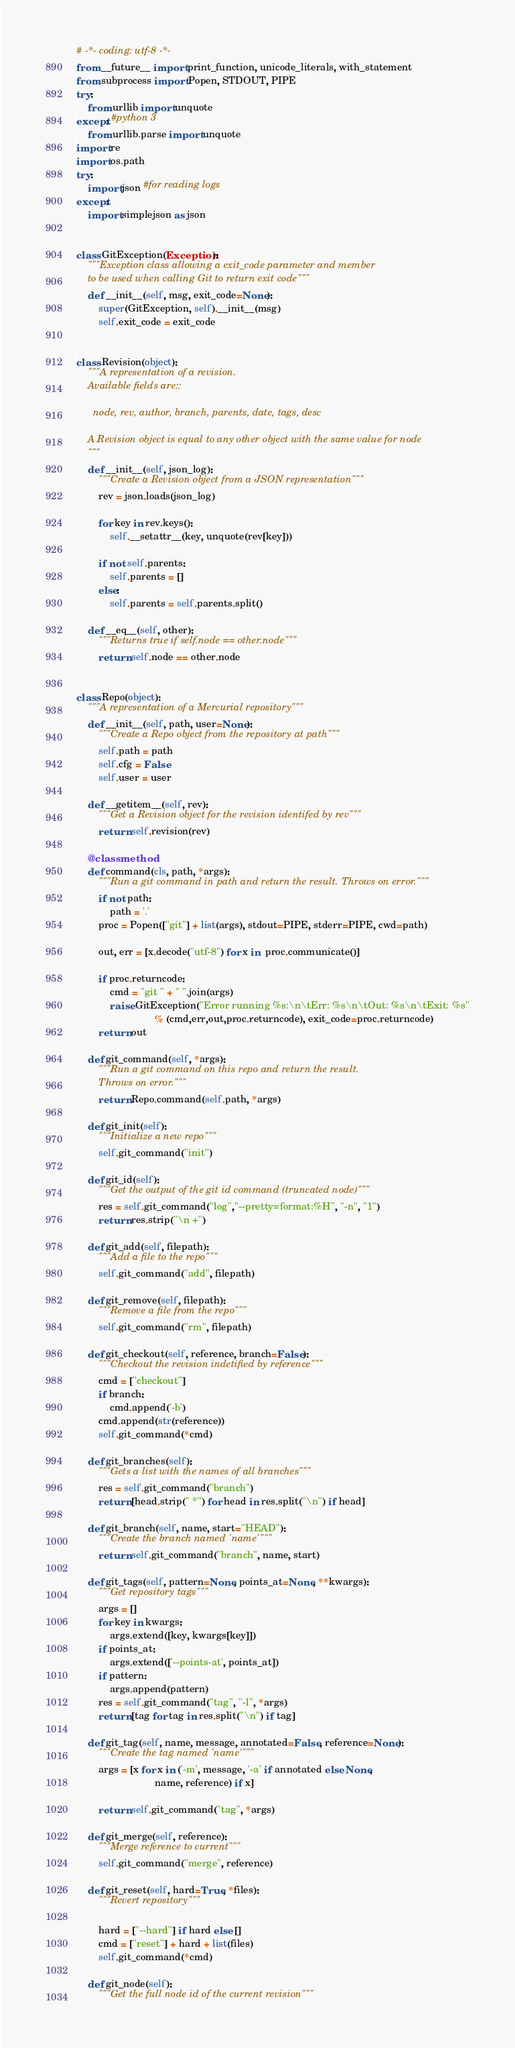<code> <loc_0><loc_0><loc_500><loc_500><_Python_># -*- coding: utf-8 -*-
from __future__ import print_function, unicode_literals, with_statement
from subprocess import Popen, STDOUT, PIPE
try:
    from urllib import unquote
except: #python 3
    from urllib.parse import unquote
import re
import os.path
try:
    import json #for reading logs
except:
    import simplejson as json


class GitException(Exception):
    """Exception class allowing a exit_code parameter and member
    to be used when calling Git to return exit code"""
    def __init__(self, msg, exit_code=None):
        super(GitException, self).__init__(msg)
        self.exit_code = exit_code


class Revision(object):
    """A representation of a revision.
    Available fields are::

      node, rev, author, branch, parents, date, tags, desc

    A Revision object is equal to any other object with the same value for node
    """
    def __init__(self, json_log):
        """Create a Revision object from a JSON representation"""
        rev = json.loads(json_log)

        for key in rev.keys():
            self.__setattr__(key, unquote(rev[key]))

        if not self.parents:
            self.parents = []
        else:
            self.parents = self.parents.split()

    def __eq__(self, other):
        """Returns true if self.node == other.node"""
        return self.node == other.node


class Repo(object):
    """A representation of a Mercurial repository"""
    def __init__(self, path, user=None):
        """Create a Repo object from the repository at path"""
        self.path = path
        self.cfg = False
        self.user = user

    def __getitem__(self, rev):
        """Get a Revision object for the revision identifed by rev"""
        return self.revision(rev)

    @classmethod
    def command(cls, path, *args):
        """Run a git command in path and return the result. Throws on error."""
        if not path:
            path = '.'
        proc = Popen(["git"] + list(args), stdout=PIPE, stderr=PIPE, cwd=path)

        out, err = [x.decode("utf-8") for x in  proc.communicate()]

        if proc.returncode:
            cmd = "git " + " ".join(args)
            raise GitException("Error running %s:\n\tErr: %s\n\tOut: %s\n\tExit: %s"
                            % (cmd,err,out,proc.returncode), exit_code=proc.returncode)
        return out

    def git_command(self, *args):
        """Run a git command on this repo and return the result.
        Throws on error."""
        return Repo.command(self.path, *args)

    def git_init(self):
        """Initialize a new repo"""
        self.git_command("init")

    def git_id(self):
        """Get the output of the git id command (truncated node)"""
        res = self.git_command("log","--pretty=format:%H", "-n", "1")
        return res.strip("\n +")

    def git_add(self, filepath):
        """Add a file to the repo"""
        self.git_command("add", filepath)

    def git_remove(self, filepath):
        """Remove a file from the repo"""
        self.git_command("rm", filepath)

    def git_checkout(self, reference, branch=False):
        """Checkout the revision indetified by reference"""
        cmd = ["checkout"]
        if branch:
            cmd.append('-b')
        cmd.append(str(reference))
        self.git_command(*cmd)

    def git_branches(self):
        """Gets a list with the names of all branches"""
        res = self.git_command("branch")
        return [head.strip(" *") for head in res.split("\n") if head]

    def git_branch(self, name, start="HEAD"):
        """Create the branch named 'name'"""
        return self.git_command("branch", name, start)

    def git_tags(self, pattern=None, points_at=None, **kwargs):
        """Get repository tags"""
        args = []
        for key in kwargs:
            args.extend([key, kwargs[key]])
        if points_at:
            args.extend(['--points-at', points_at])
        if pattern:
            args.append(pattern)
        res = self.git_command("tag", "-l", *args)
        return [tag for tag in res.split("\n") if tag]

    def git_tag(self, name, message, annotated=False, reference=None):
        """Create the tag named 'name'"""
        args = [x for x in ('-m', message, '-a' if annotated else None,
                            name, reference) if x]

        return self.git_command("tag", *args)

    def git_merge(self, reference):
        """Merge reference to current"""
        self.git_command("merge", reference)

    def git_reset(self, hard=True, *files):
        """Revert repository"""

        hard = ["--hard"] if hard else []
        cmd = ["reset"] + hard + list(files)
        self.git_command(*cmd)

    def git_node(self):
        """Get the full node id of the current revision"""</code> 